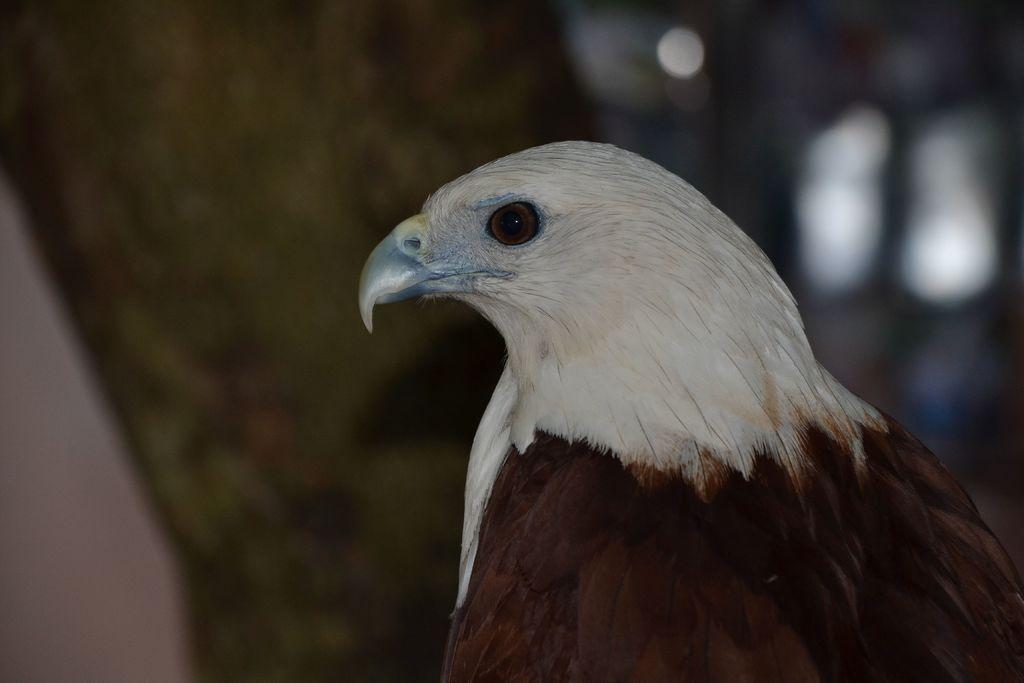Please provide a concise description of this image. In the center of the image, we can see a bird and in the background, there is a tree. 